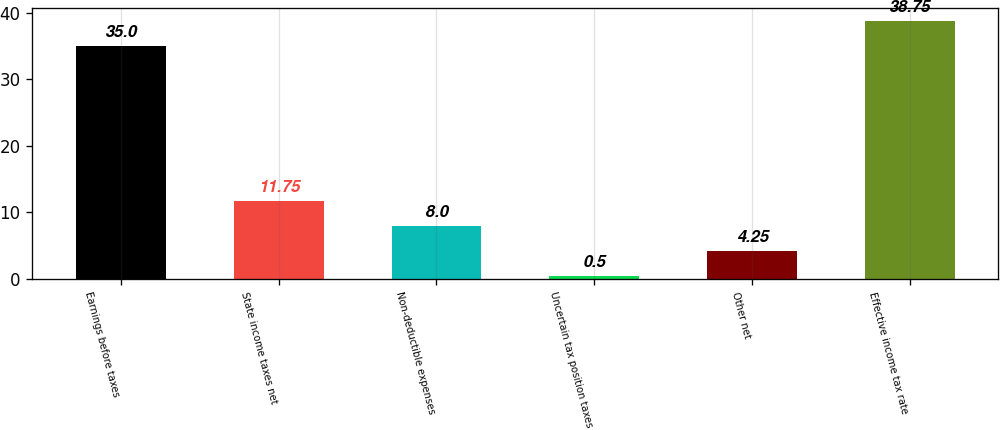Convert chart to OTSL. <chart><loc_0><loc_0><loc_500><loc_500><bar_chart><fcel>Earnings before taxes<fcel>State income taxes net<fcel>Non-deductible expenses<fcel>Uncertain tax position taxes<fcel>Other net<fcel>Effective income tax rate<nl><fcel>35<fcel>11.75<fcel>8<fcel>0.5<fcel>4.25<fcel>38.75<nl></chart> 